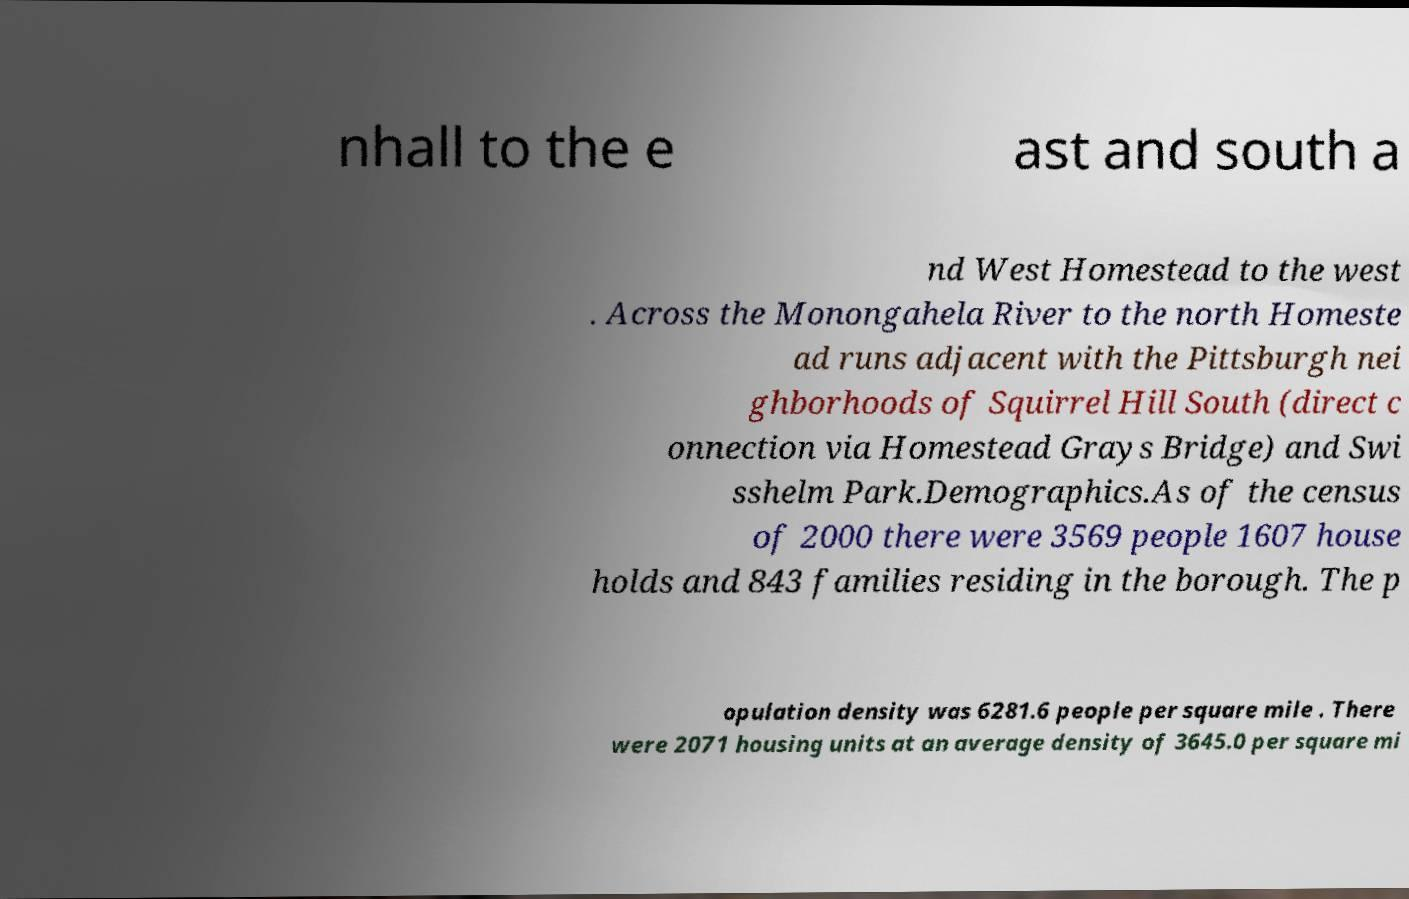Could you extract and type out the text from this image? nhall to the e ast and south a nd West Homestead to the west . Across the Monongahela River to the north Homeste ad runs adjacent with the Pittsburgh nei ghborhoods of Squirrel Hill South (direct c onnection via Homestead Grays Bridge) and Swi sshelm Park.Demographics.As of the census of 2000 there were 3569 people 1607 house holds and 843 families residing in the borough. The p opulation density was 6281.6 people per square mile . There were 2071 housing units at an average density of 3645.0 per square mi 